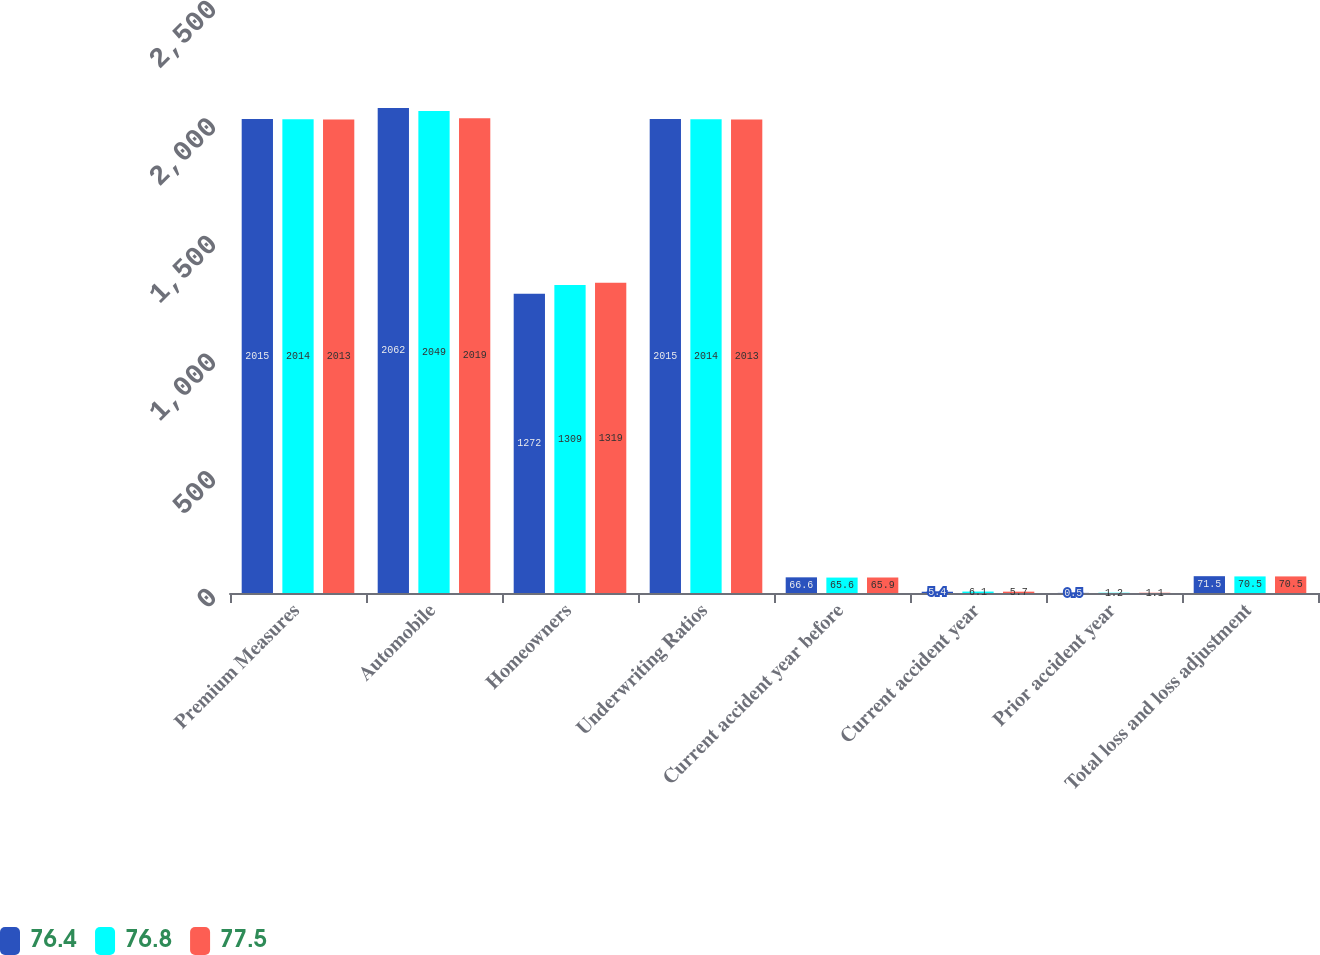Convert chart to OTSL. <chart><loc_0><loc_0><loc_500><loc_500><stacked_bar_chart><ecel><fcel>Premium Measures<fcel>Automobile<fcel>Homeowners<fcel>Underwriting Ratios<fcel>Current accident year before<fcel>Current accident year<fcel>Prior accident year<fcel>Total loss and loss adjustment<nl><fcel>76.4<fcel>2015<fcel>2062<fcel>1272<fcel>2015<fcel>66.6<fcel>5.4<fcel>0.5<fcel>71.5<nl><fcel>76.8<fcel>2014<fcel>2049<fcel>1309<fcel>2014<fcel>65.6<fcel>6.1<fcel>1.2<fcel>70.5<nl><fcel>77.5<fcel>2013<fcel>2019<fcel>1319<fcel>2013<fcel>65.9<fcel>5.7<fcel>1.1<fcel>70.5<nl></chart> 